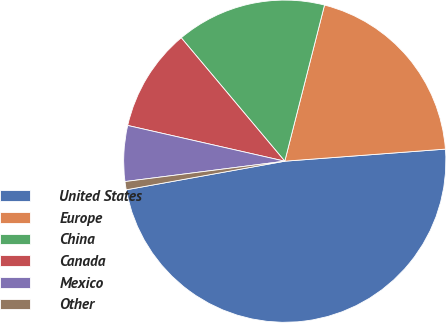Convert chart. <chart><loc_0><loc_0><loc_500><loc_500><pie_chart><fcel>United States<fcel>Europe<fcel>China<fcel>Canada<fcel>Mexico<fcel>Other<nl><fcel>48.36%<fcel>19.84%<fcel>15.08%<fcel>10.33%<fcel>5.58%<fcel>0.82%<nl></chart> 